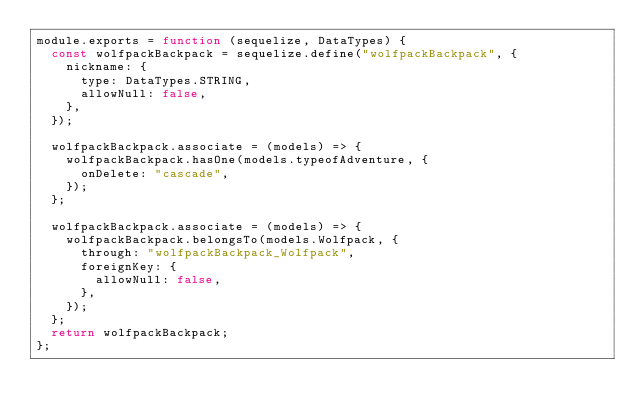Convert code to text. <code><loc_0><loc_0><loc_500><loc_500><_JavaScript_>module.exports = function (sequelize, DataTypes) {
  const wolfpackBackpack = sequelize.define("wolfpackBackpack", {
    nickname: {
      type: DataTypes.STRING,
      allowNull: false,
    },
  });
  
  wolfpackBackpack.associate = (models) => {
    wolfpackBackpack.hasOne(models.typeofAdventure, {
      onDelete: "cascade",
    });
  };
 
  wolfpackBackpack.associate = (models) => {
    wolfpackBackpack.belongsTo(models.Wolfpack, {
      through: "wolfpackBackpack_Wolfpack",
      foreignKey: {
        allowNull: false,
      },
    });
  };
  return wolfpackBackpack;
};

</code> 